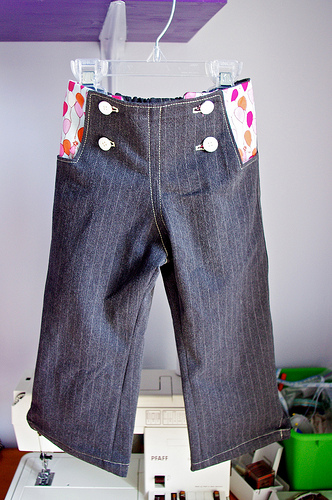<image>
Is the button on the pants? Yes. Looking at the image, I can see the button is positioned on top of the pants, with the pants providing support. Where is the sewing machine in relation to the pants? Is it under the pants? Yes. The sewing machine is positioned underneath the pants, with the pants above it in the vertical space. 